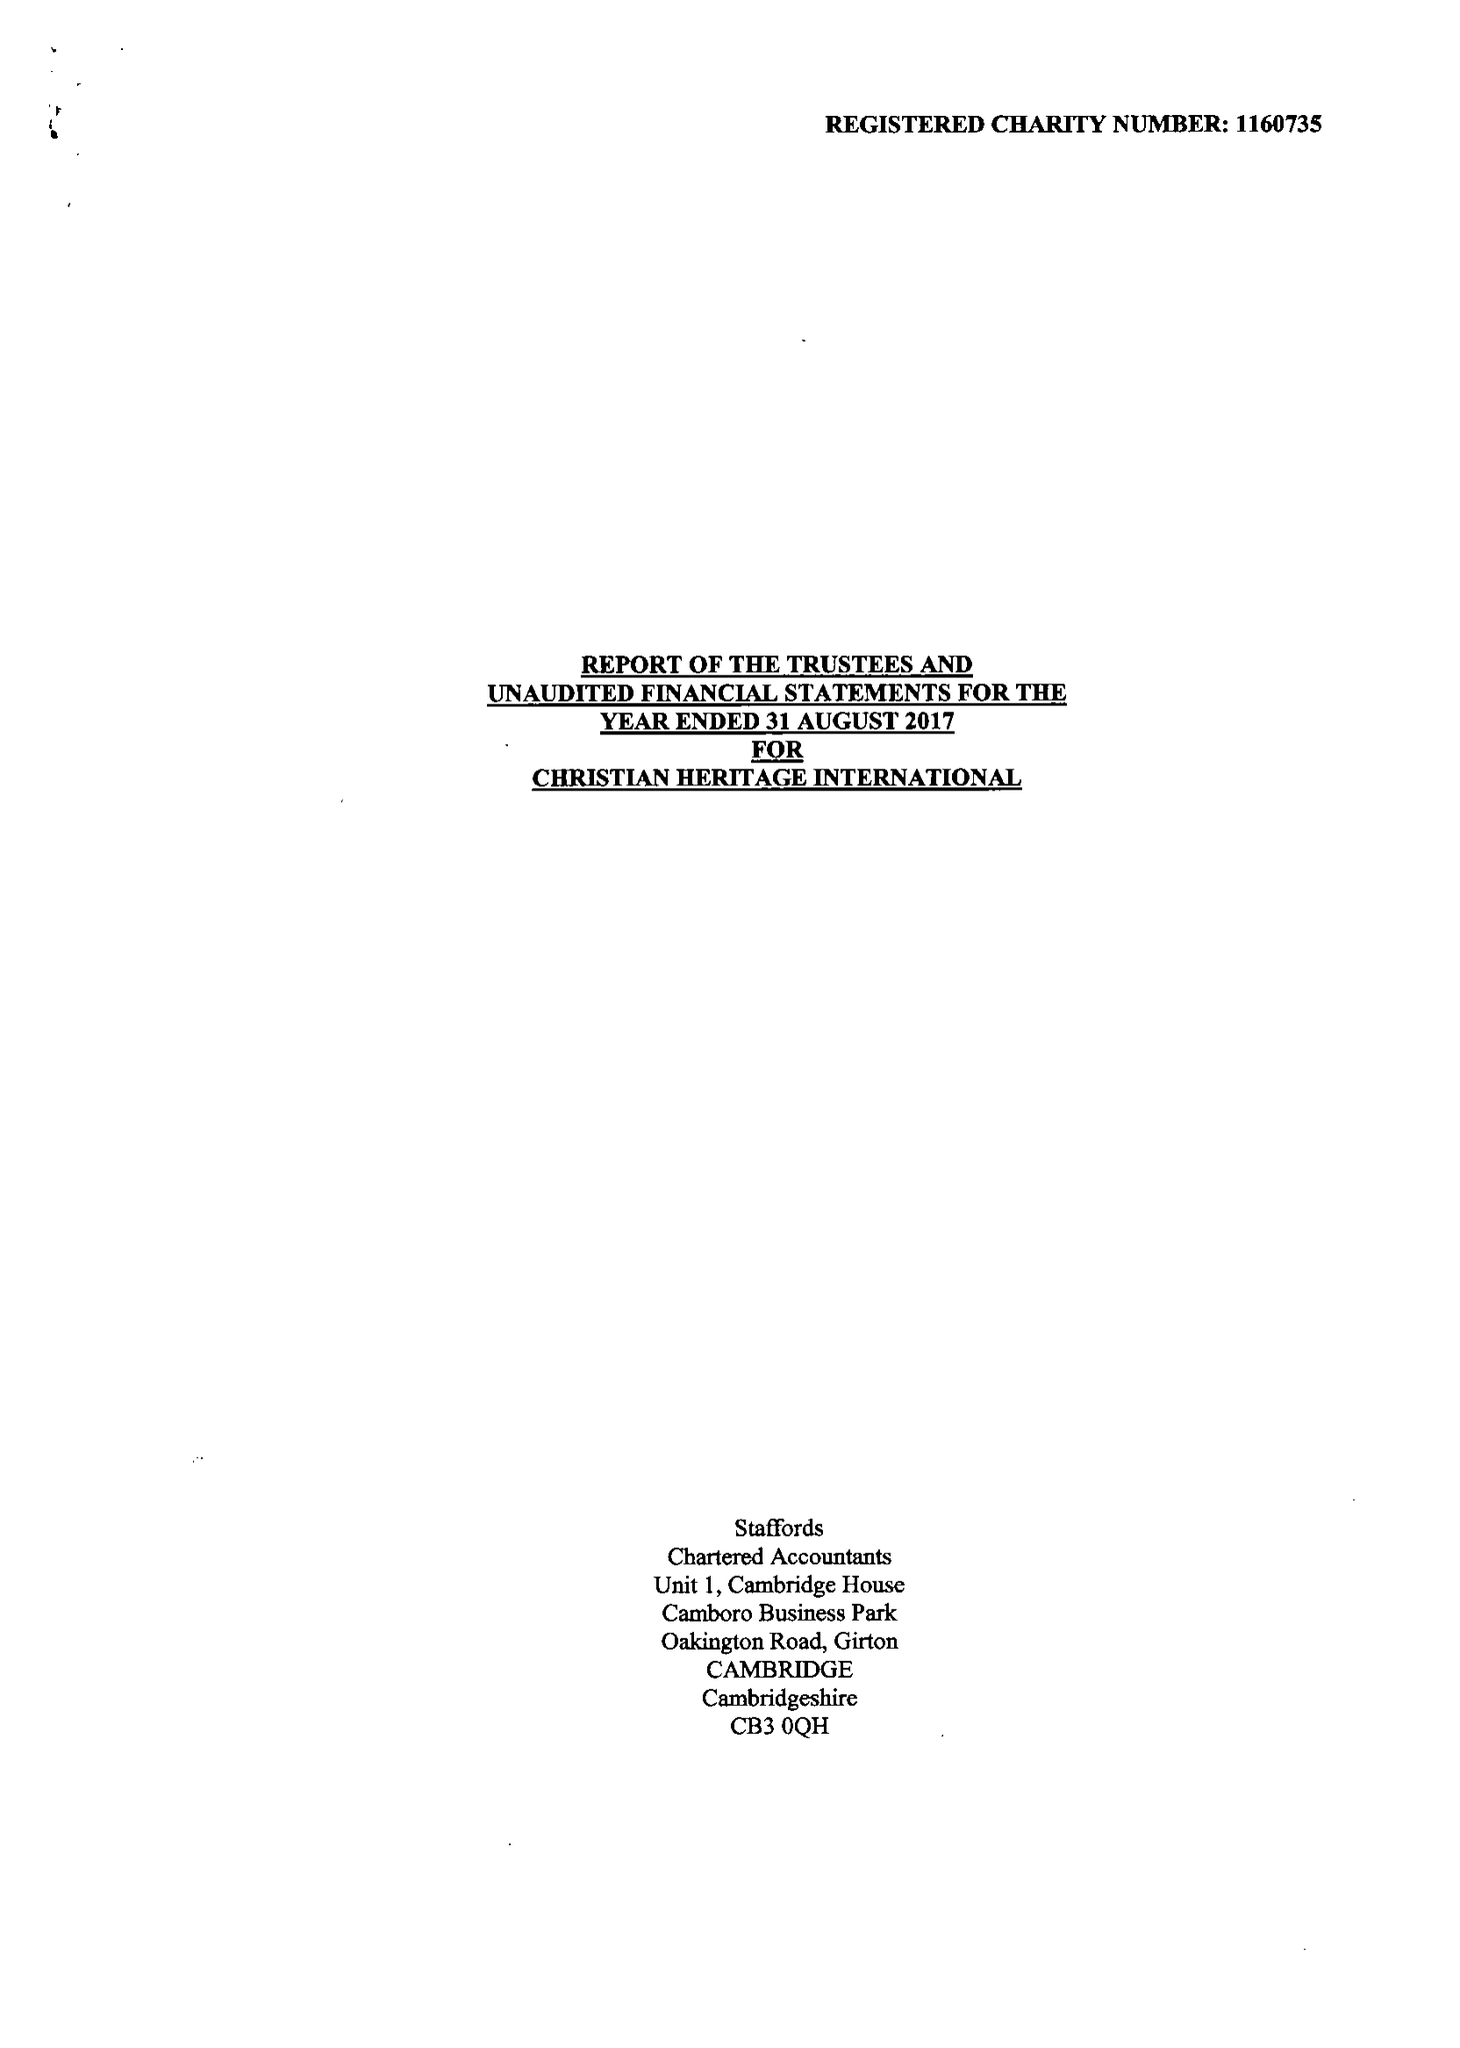What is the value for the charity_name?
Answer the question using a single word or phrase. Christian Heritage International 